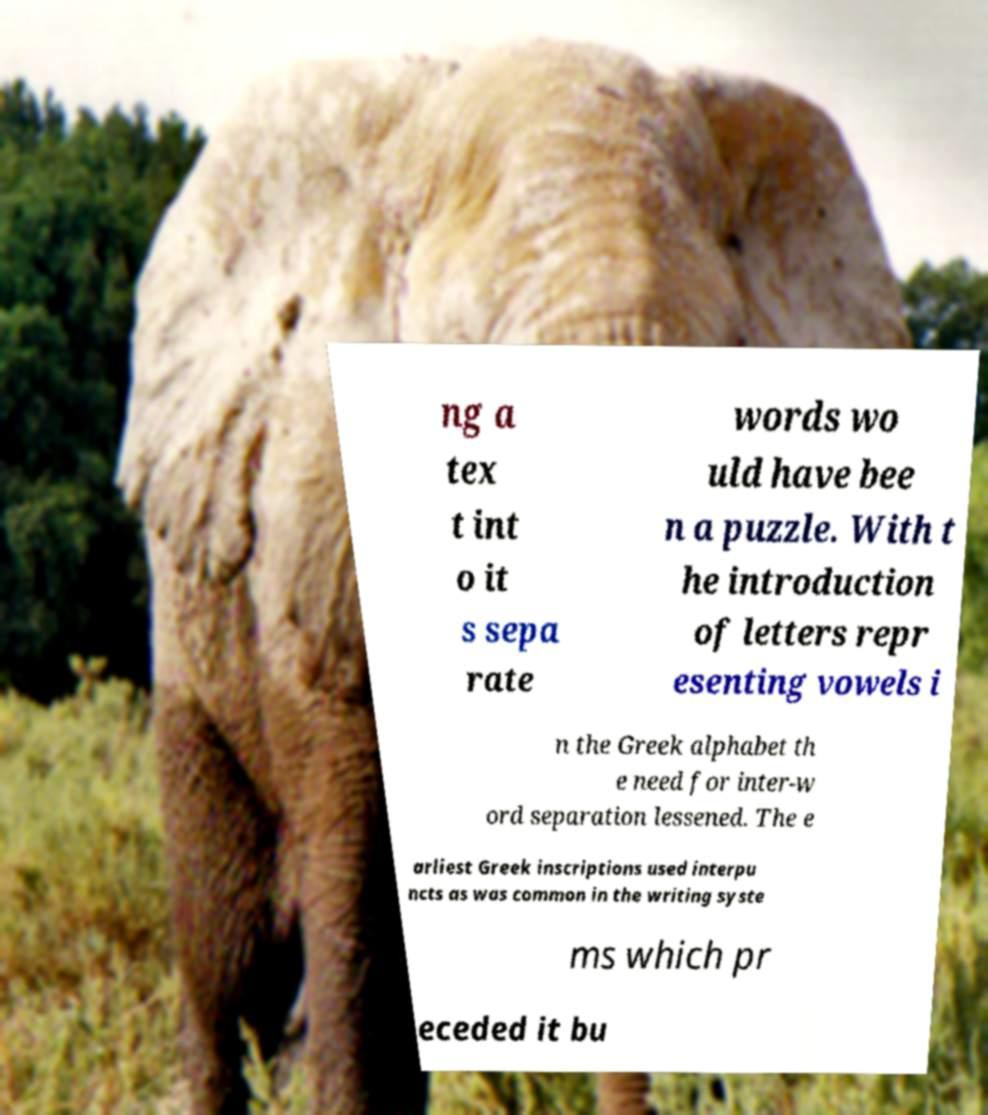Could you assist in decoding the text presented in this image and type it out clearly? ng a tex t int o it s sepa rate words wo uld have bee n a puzzle. With t he introduction of letters repr esenting vowels i n the Greek alphabet th e need for inter-w ord separation lessened. The e arliest Greek inscriptions used interpu ncts as was common in the writing syste ms which pr eceded it bu 